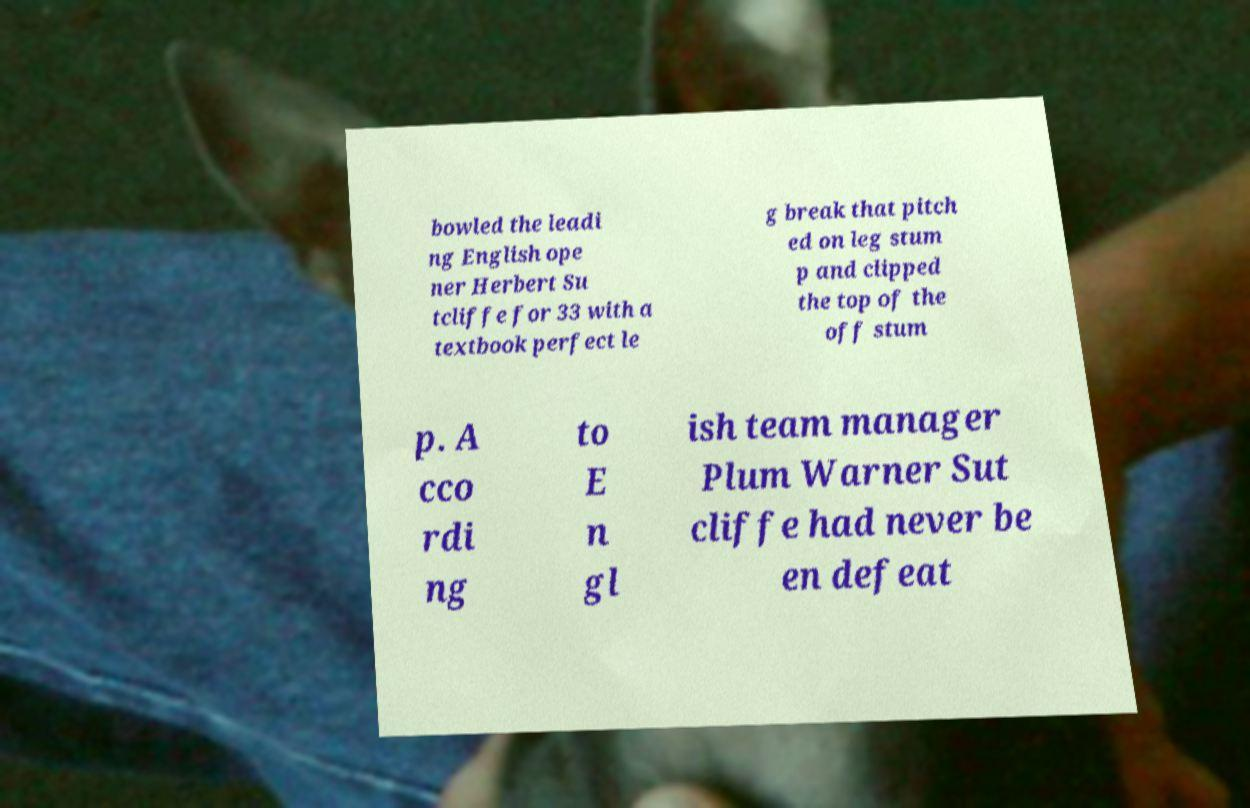Can you accurately transcribe the text from the provided image for me? bowled the leadi ng English ope ner Herbert Su tcliffe for 33 with a textbook perfect le g break that pitch ed on leg stum p and clipped the top of the off stum p. A cco rdi ng to E n gl ish team manager Plum Warner Sut cliffe had never be en defeat 